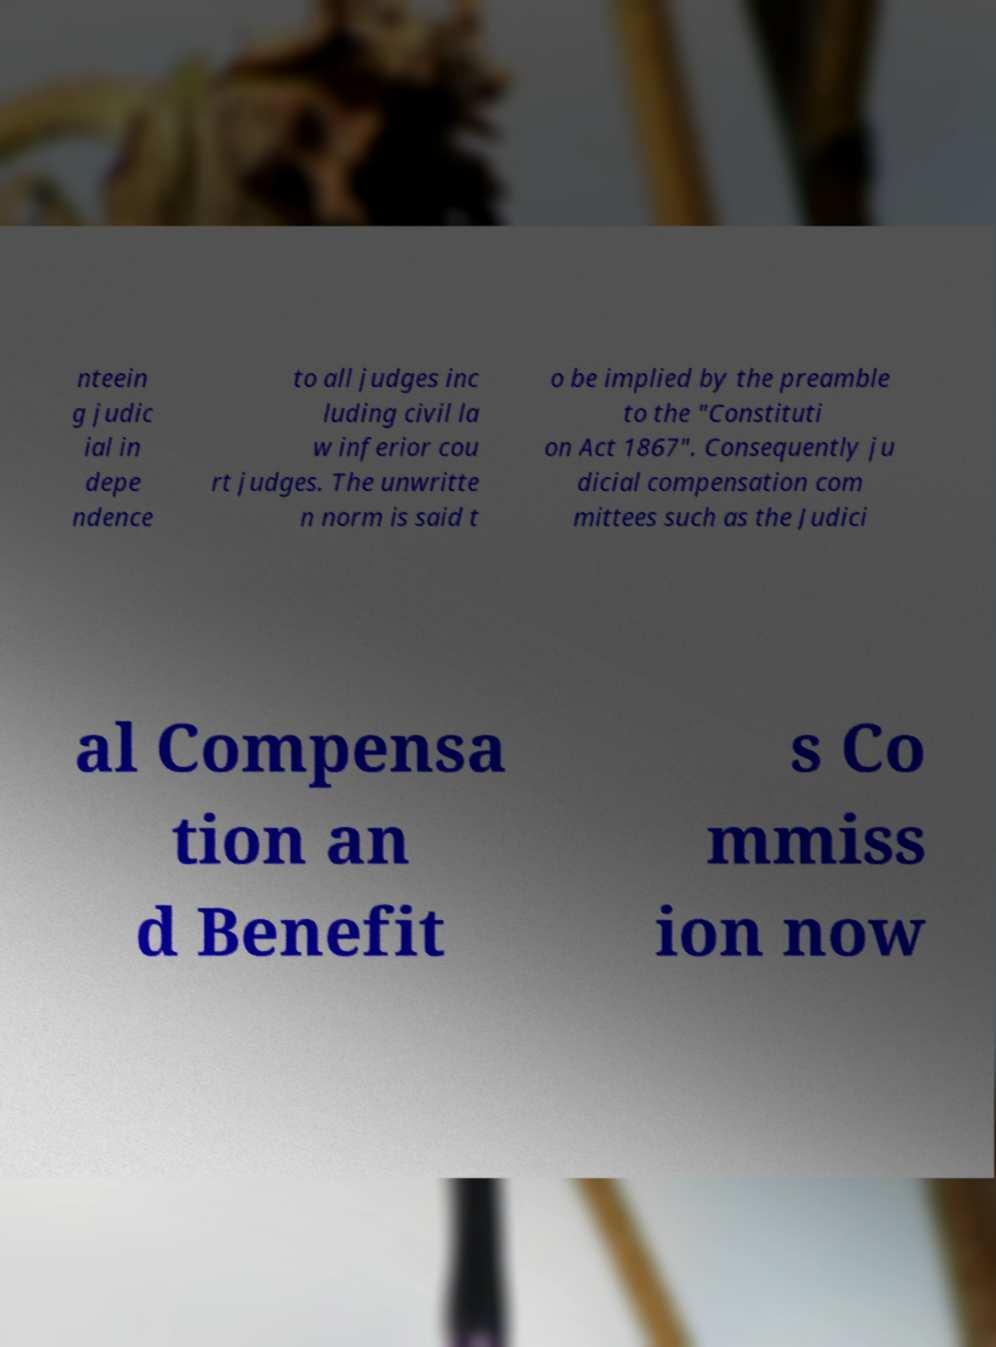What messages or text are displayed in this image? I need them in a readable, typed format. nteein g judic ial in depe ndence to all judges inc luding civil la w inferior cou rt judges. The unwritte n norm is said t o be implied by the preamble to the "Constituti on Act 1867". Consequently ju dicial compensation com mittees such as the Judici al Compensa tion an d Benefit s Co mmiss ion now 